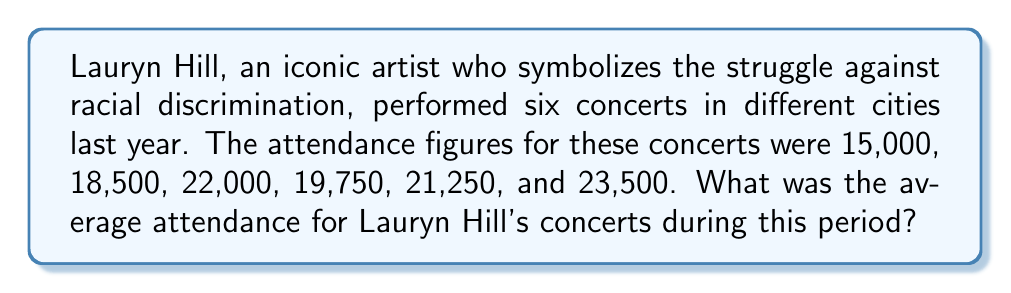What is the answer to this math problem? To find the average attendance, we need to follow these steps:

1. Sum up all the attendance figures:
   $$15,000 + 18,500 + 22,000 + 19,750 + 21,250 + 23,500$$

2. Calculate the total:
   $$120,000$$

3. Count the number of concerts:
   There were 6 concerts.

4. Divide the total attendance by the number of concerts:
   $$\frac{120,000}{6} = 20,000$$

Therefore, the average attendance for Lauryn Hill's concerts during this period was 20,000 people.
Answer: $20,000$ 